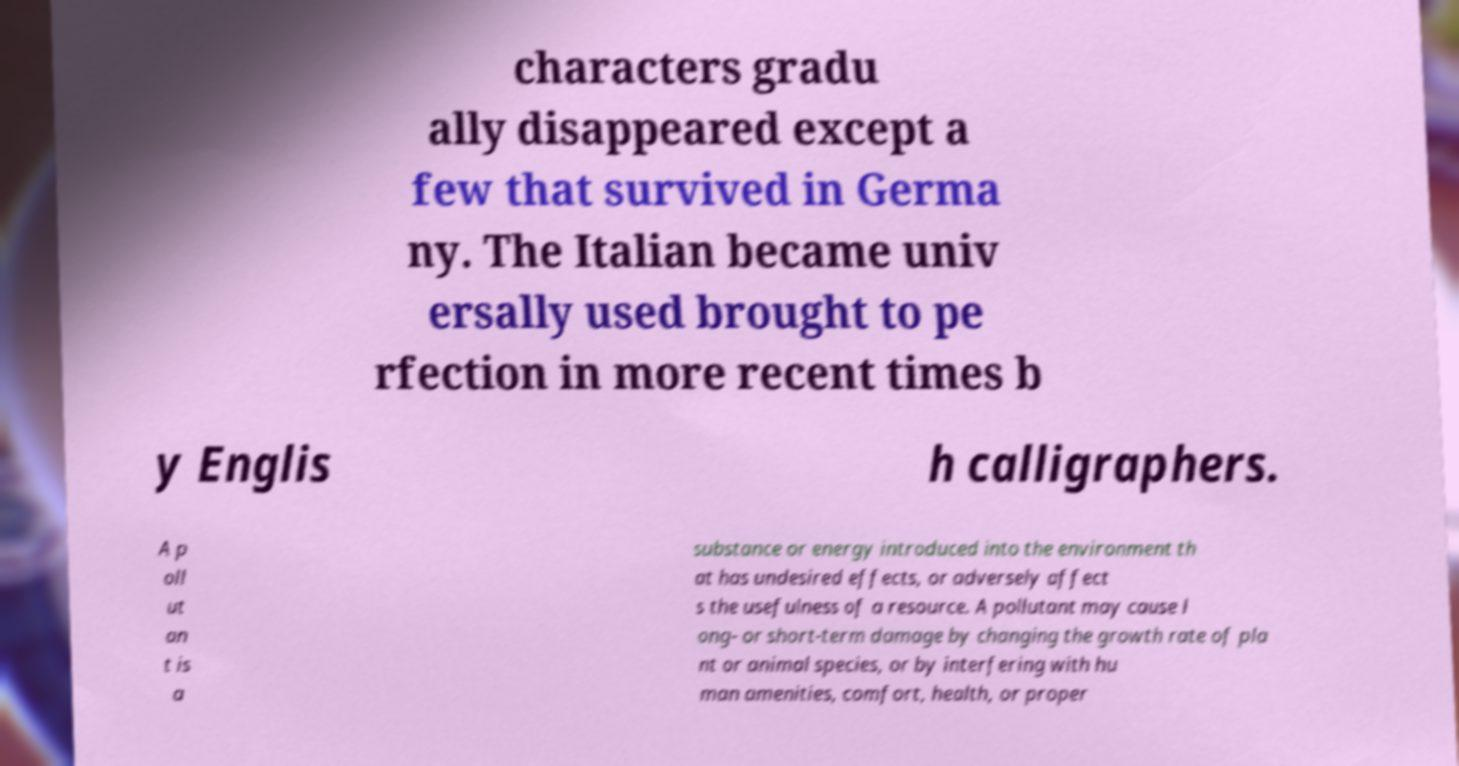There's text embedded in this image that I need extracted. Can you transcribe it verbatim? characters gradu ally disappeared except a few that survived in Germa ny. The Italian became univ ersally used brought to pe rfection in more recent times b y Englis h calligraphers. A p oll ut an t is a substance or energy introduced into the environment th at has undesired effects, or adversely affect s the usefulness of a resource. A pollutant may cause l ong- or short-term damage by changing the growth rate of pla nt or animal species, or by interfering with hu man amenities, comfort, health, or proper 